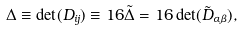<formula> <loc_0><loc_0><loc_500><loc_500>\Delta \equiv \det ( D _ { i j } ) \equiv 1 6 \tilde { \Delta } = 1 6 \det ( \tilde { D } _ { \alpha \beta } ) ,</formula> 